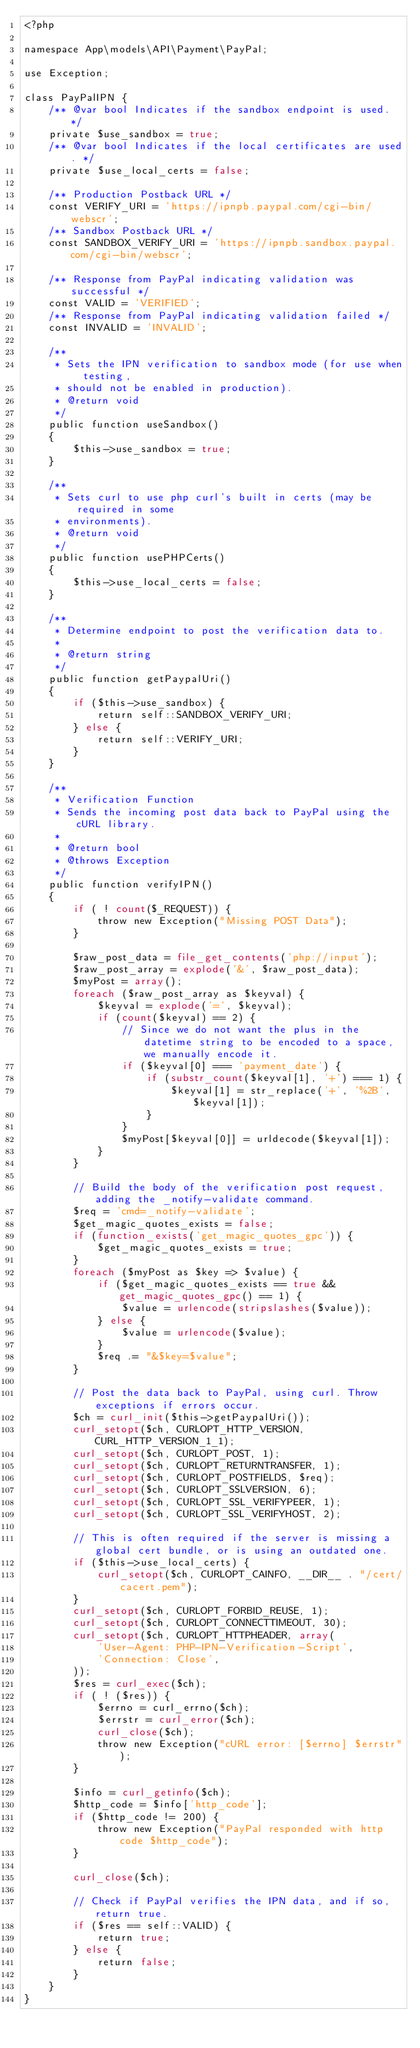Convert code to text. <code><loc_0><loc_0><loc_500><loc_500><_PHP_><?php

namespace App\models\API\Payment\PayPal;

use Exception;

class PayPalIPN {
    /** @var bool Indicates if the sandbox endpoint is used. */
    private $use_sandbox = true;
    /** @var bool Indicates if the local certificates are used. */
    private $use_local_certs = false;

    /** Production Postback URL */
    const VERIFY_URI = 'https://ipnpb.paypal.com/cgi-bin/webscr';
    /** Sandbox Postback URL */
    const SANDBOX_VERIFY_URI = 'https://ipnpb.sandbox.paypal.com/cgi-bin/webscr';

    /** Response from PayPal indicating validation was successful */
    const VALID = 'VERIFIED';
    /** Response from PayPal indicating validation failed */
    const INVALID = 'INVALID';

    /**
     * Sets the IPN verification to sandbox mode (for use when testing,
     * should not be enabled in production).
     * @return void
     */
    public function useSandbox()
    {
        $this->use_sandbox = true;
    }

    /**
     * Sets curl to use php curl's built in certs (may be required in some
     * environments).
     * @return void
     */
    public function usePHPCerts()
    {
        $this->use_local_certs = false;
    }

    /**
     * Determine endpoint to post the verification data to.
     *
     * @return string
     */
    public function getPaypalUri()
    {
        if ($this->use_sandbox) {
            return self::SANDBOX_VERIFY_URI;
        } else {
            return self::VERIFY_URI;
        }
    }

    /**
     * Verification Function
     * Sends the incoming post data back to PayPal using the cURL library.
     *
     * @return bool
     * @throws Exception
     */
    public function verifyIPN()
    {
        if ( ! count($_REQUEST)) {
            throw new Exception("Missing POST Data");
        }

        $raw_post_data = file_get_contents('php://input');
        $raw_post_array = explode('&', $raw_post_data);
        $myPost = array();
        foreach ($raw_post_array as $keyval) {
            $keyval = explode('=', $keyval);
            if (count($keyval) == 2) {
                // Since we do not want the plus in the datetime string to be encoded to a space, we manually encode it.
                if ($keyval[0] === 'payment_date') {
                    if (substr_count($keyval[1], '+') === 1) {
                        $keyval[1] = str_replace('+', '%2B', $keyval[1]);
                    }
                }
                $myPost[$keyval[0]] = urldecode($keyval[1]);
            }
        }

        // Build the body of the verification post request, adding the _notify-validate command.
        $req = 'cmd=_notify-validate';
        $get_magic_quotes_exists = false;
        if (function_exists('get_magic_quotes_gpc')) {
            $get_magic_quotes_exists = true;
        }
        foreach ($myPost as $key => $value) {
            if ($get_magic_quotes_exists == true && get_magic_quotes_gpc() == 1) {
                $value = urlencode(stripslashes($value));
            } else {
                $value = urlencode($value);
            }
            $req .= "&$key=$value";
        }

        // Post the data back to PayPal, using curl. Throw exceptions if errors occur.
        $ch = curl_init($this->getPaypalUri());
        curl_setopt($ch, CURLOPT_HTTP_VERSION, CURL_HTTP_VERSION_1_1);
        curl_setopt($ch, CURLOPT_POST, 1);
        curl_setopt($ch, CURLOPT_RETURNTRANSFER, 1);
        curl_setopt($ch, CURLOPT_POSTFIELDS, $req);
        curl_setopt($ch, CURLOPT_SSLVERSION, 6);
        curl_setopt($ch, CURLOPT_SSL_VERIFYPEER, 1);
        curl_setopt($ch, CURLOPT_SSL_VERIFYHOST, 2);

        // This is often required if the server is missing a global cert bundle, or is using an outdated one.
        if ($this->use_local_certs) {
            curl_setopt($ch, CURLOPT_CAINFO, __DIR__ . "/cert/cacert.pem");
        }
        curl_setopt($ch, CURLOPT_FORBID_REUSE, 1);
        curl_setopt($ch, CURLOPT_CONNECTTIMEOUT, 30);
        curl_setopt($ch, CURLOPT_HTTPHEADER, array(
            'User-Agent: PHP-IPN-Verification-Script',
            'Connection: Close',
        ));
        $res = curl_exec($ch);
        if ( ! ($res)) {
            $errno = curl_errno($ch);
            $errstr = curl_error($ch);
            curl_close($ch);
            throw new Exception("cURL error: [$errno] $errstr");
        }

        $info = curl_getinfo($ch);
        $http_code = $info['http_code'];
        if ($http_code != 200) {
            throw new Exception("PayPal responded with http code $http_code");
        }

        curl_close($ch);

        // Check if PayPal verifies the IPN data, and if so, return true.
        if ($res == self::VALID) {
            return true;
        } else {
            return false;
        }
    }
}
</code> 